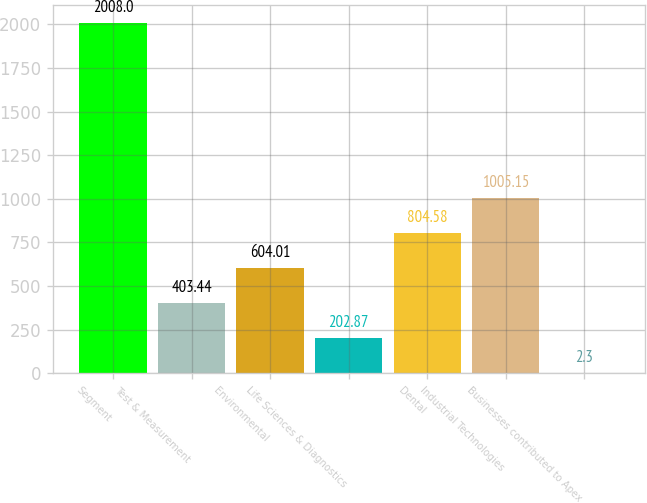Convert chart to OTSL. <chart><loc_0><loc_0><loc_500><loc_500><bar_chart><fcel>Segment<fcel>Test & Measurement<fcel>Environmental<fcel>Life Sciences & Diagnostics<fcel>Dental<fcel>Industrial Technologies<fcel>Businesses contributed to Apex<nl><fcel>2008<fcel>403.44<fcel>604.01<fcel>202.87<fcel>804.58<fcel>1005.15<fcel>2.3<nl></chart> 